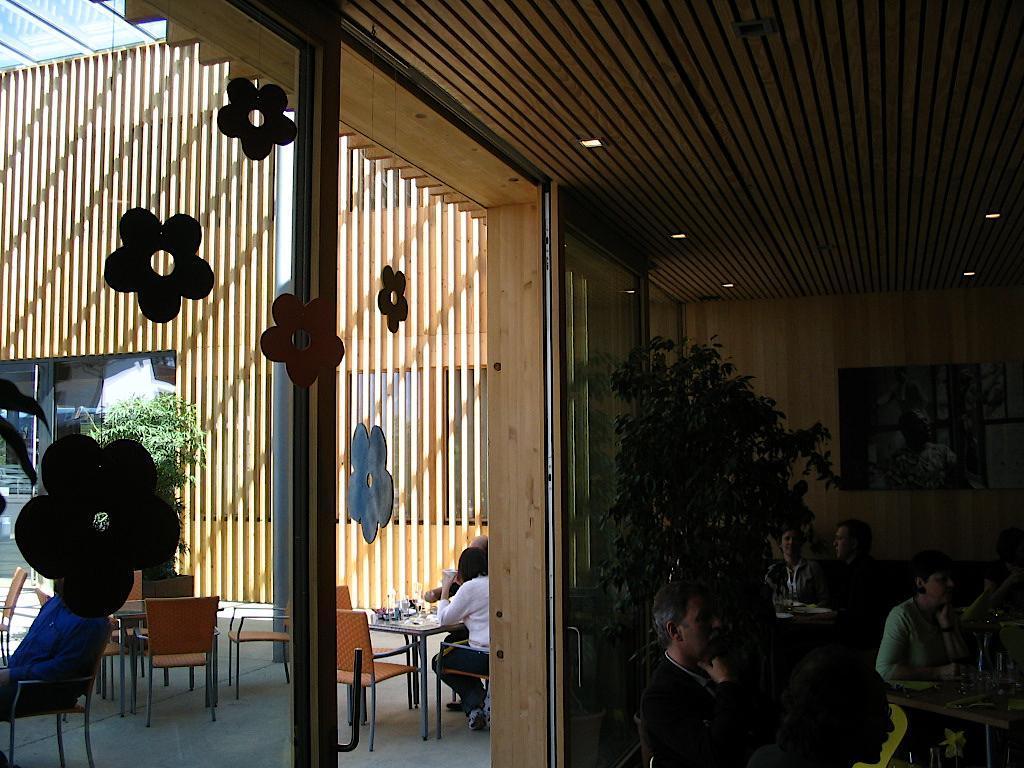Please provide a concise description of this image. In this image there are group of persons who are sitting on the chairs and tables at the left side of the image there is a window. 